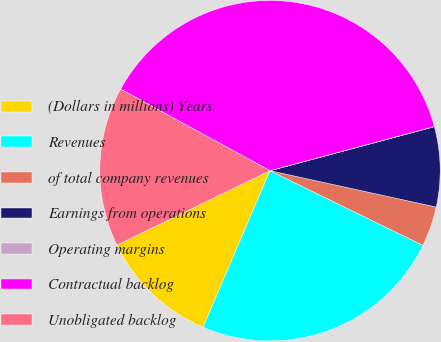<chart> <loc_0><loc_0><loc_500><loc_500><pie_chart><fcel>(Dollars in millions) Years<fcel>Revenues<fcel>of total company revenues<fcel>Earnings from operations<fcel>Operating margins<fcel>Contractual backlog<fcel>Unobligated backlog<nl><fcel>11.37%<fcel>24.2%<fcel>3.8%<fcel>7.59%<fcel>0.02%<fcel>37.87%<fcel>15.16%<nl></chart> 